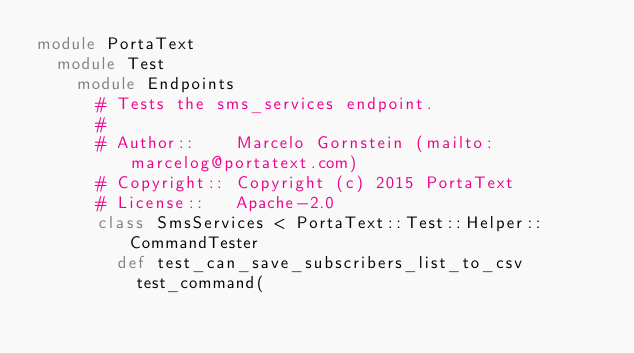<code> <loc_0><loc_0><loc_500><loc_500><_Ruby_>module PortaText
  module Test
    module Endpoints
      # Tests the sms_services endpoint.
      #
      # Author::    Marcelo Gornstein (mailto:marcelog@portatext.com)
      # Copyright:: Copyright (c) 2015 PortaText
      # License::   Apache-2.0
      class SmsServices < PortaText::Test::Helper::CommandTester
        def test_can_save_subscribers_list_to_csv
          test_command(</code> 